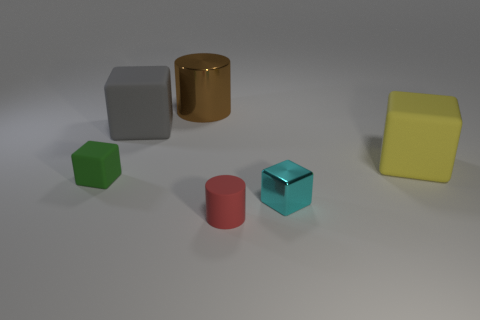Are the big yellow object and the cylinder that is behind the big gray rubber cube made of the same material?
Provide a short and direct response. No. What material is the cyan object?
Offer a terse response. Metal. How big is the matte thing that is to the right of the large gray thing and behind the red cylinder?
Provide a succinct answer. Large. Are there fewer tiny matte objects that are behind the brown cylinder than cyan cubes that are to the right of the gray rubber block?
Provide a short and direct response. Yes. Is the brown object the same size as the gray block?
Give a very brief answer. Yes. What shape is the rubber object that is both in front of the yellow cube and right of the tiny green object?
Give a very brief answer. Cylinder. What number of cyan cubes are the same material as the brown thing?
Ensure brevity in your answer.  1. There is a small rubber object that is to the left of the red object; what number of yellow matte things are in front of it?
Keep it short and to the point. 0. There is a metallic thing that is behind the large matte cube to the left of the big cylinder behind the yellow rubber thing; what is its shape?
Your answer should be compact. Cylinder. How many objects are red things or gray cubes?
Give a very brief answer. 2. 